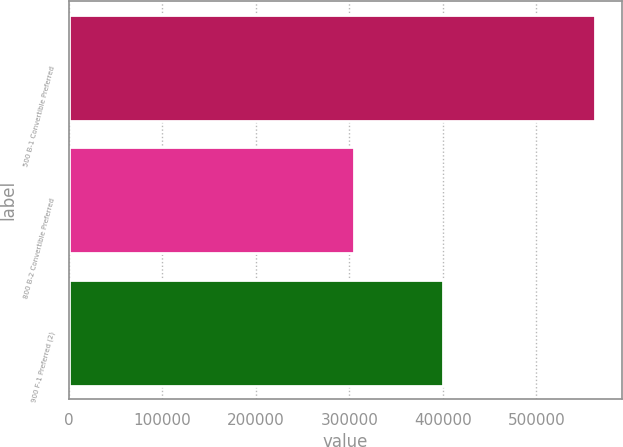Convert chart. <chart><loc_0><loc_0><loc_500><loc_500><bar_chart><fcel>500 B-1 Convertible Preferred<fcel>800 B-2 Convertible Preferred<fcel>900 F-1 Preferred (2)<nl><fcel>563263<fcel>304761<fcel>400000<nl></chart> 